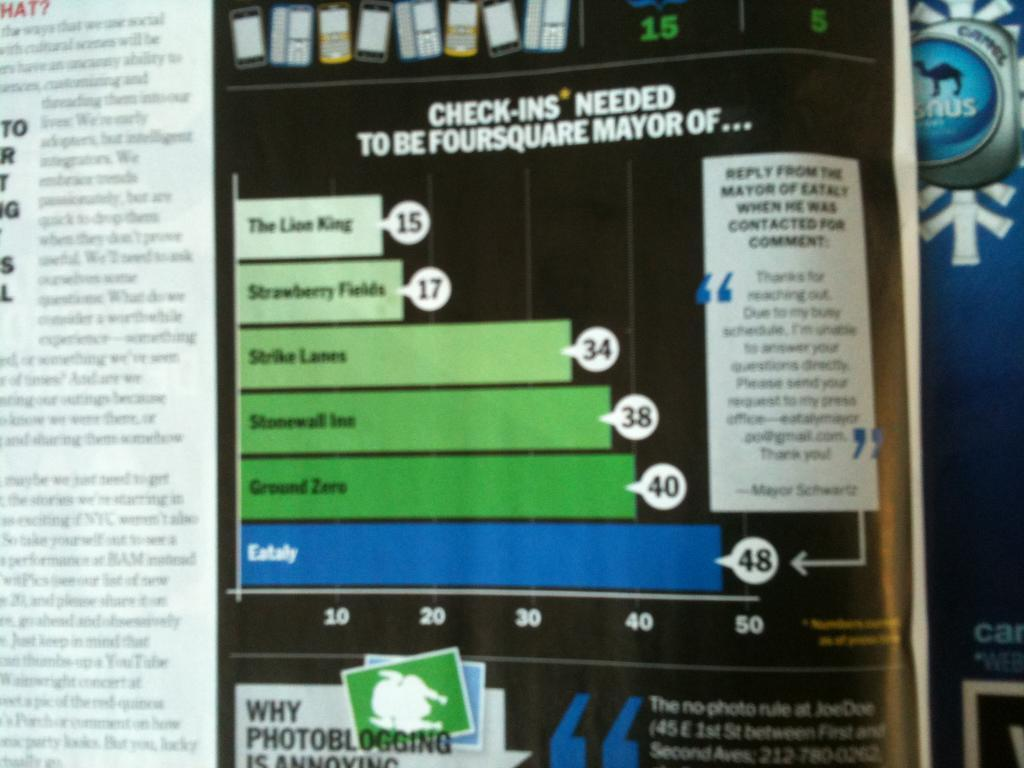<image>
Give a short and clear explanation of the subsequent image. A printed page has the phrase check-ins needed at the top of the page. 